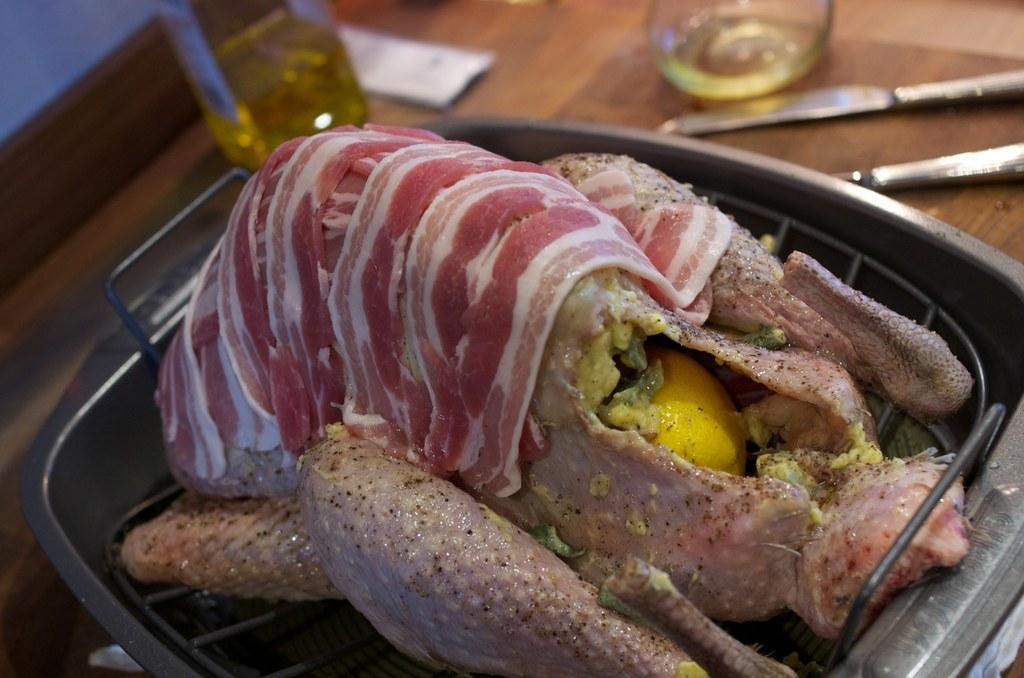Could you give a brief overview of what you see in this image? In the picture we can see a tray in that we can see a chicken and some meat pieces on it and beside the tree we can see some knife and a glass with some drink. 